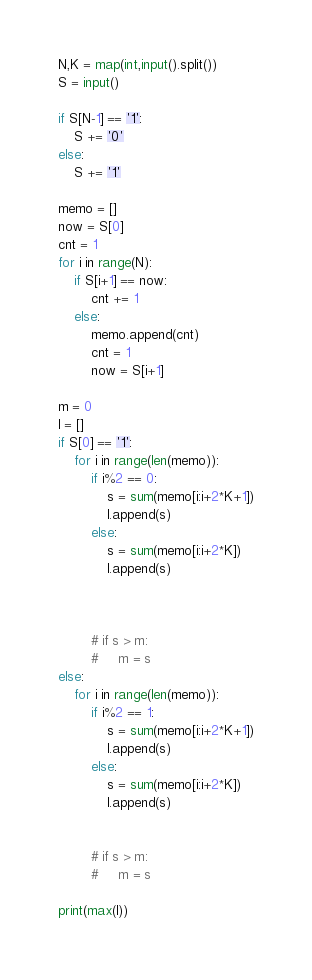Convert code to text. <code><loc_0><loc_0><loc_500><loc_500><_Python_>N,K = map(int,input().split())
S = input()

if S[N-1] == '1':
    S += '0'
else:
    S += '1'

memo = []
now = S[0]
cnt = 1
for i in range(N):
    if S[i+1] == now:
        cnt += 1
    else:
        memo.append(cnt)
        cnt = 1
        now = S[i+1]

m = 0
l = []
if S[0] == '1':
    for i in range(len(memo)):
        if i%2 == 0:
            s = sum(memo[i:i+2*K+1])
            l.append(s)
        else:
            s = sum(memo[i:i+2*K])
            l.append(s)



        # if s > m:
        #     m = s
else:
    for i in range(len(memo)):
        if i%2 == 1:
            s = sum(memo[i:i+2*K+1])
            l.append(s)
        else:
            s = sum(memo[i:i+2*K])
            l.append(s)


        # if s > m:
        #     m = s

print(max(l))

</code> 